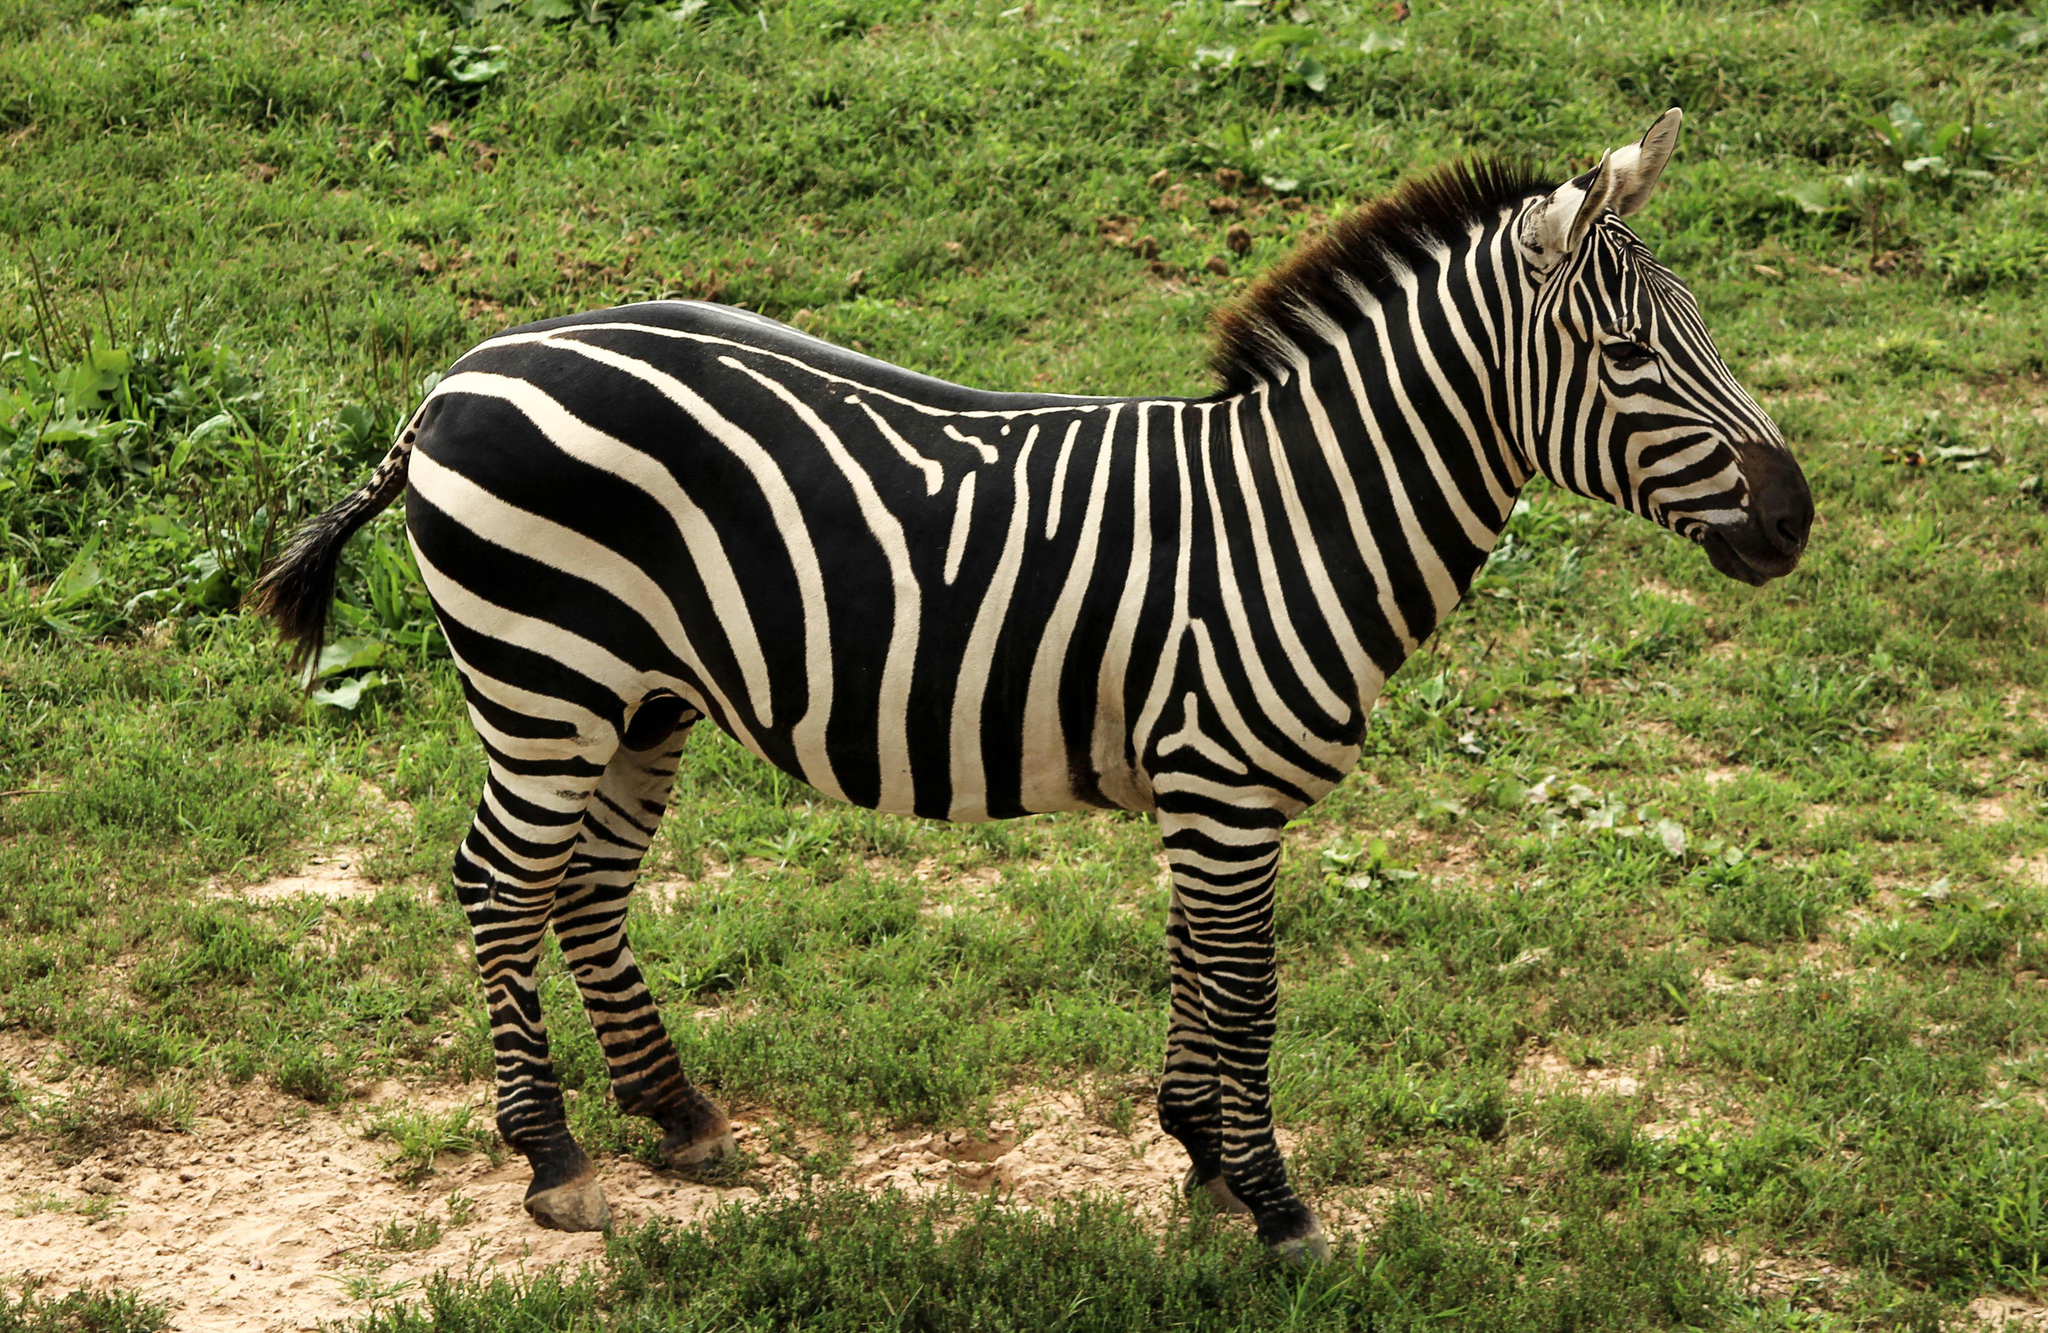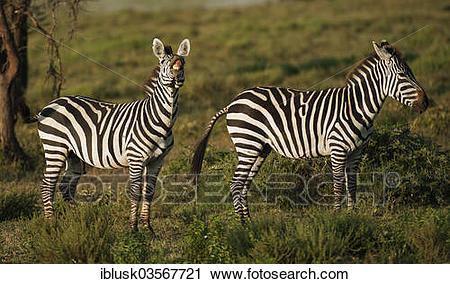The first image is the image on the left, the second image is the image on the right. Assess this claim about the two images: "There is a single zebra in one image.". Correct or not? Answer yes or no. Yes. The first image is the image on the left, the second image is the image on the right. For the images shown, is this caption "Here we have exactly three zebras." true? Answer yes or no. Yes. 